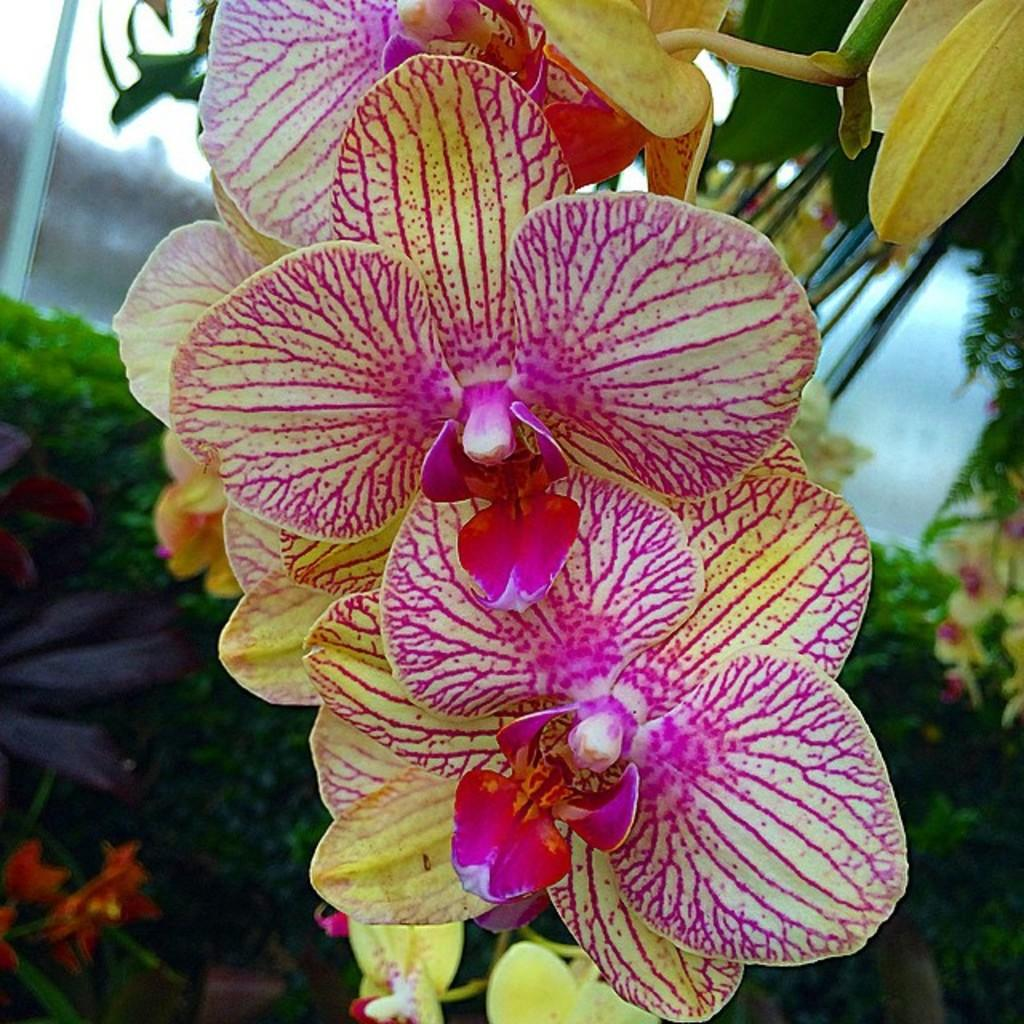What type of flora can be seen in the image? There are flowers in the image. What colors are the flowers? The flowers are pink and yellow in color. What else can be seen in the background of the image? There are plants and bushes in the background of the image. Where is the crib located in the image? There is no crib present in the image. 